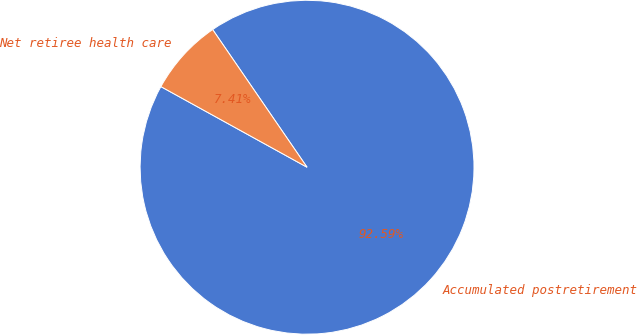<chart> <loc_0><loc_0><loc_500><loc_500><pie_chart><fcel>Accumulated postretirement<fcel>Net retiree health care<nl><fcel>92.59%<fcel>7.41%<nl></chart> 